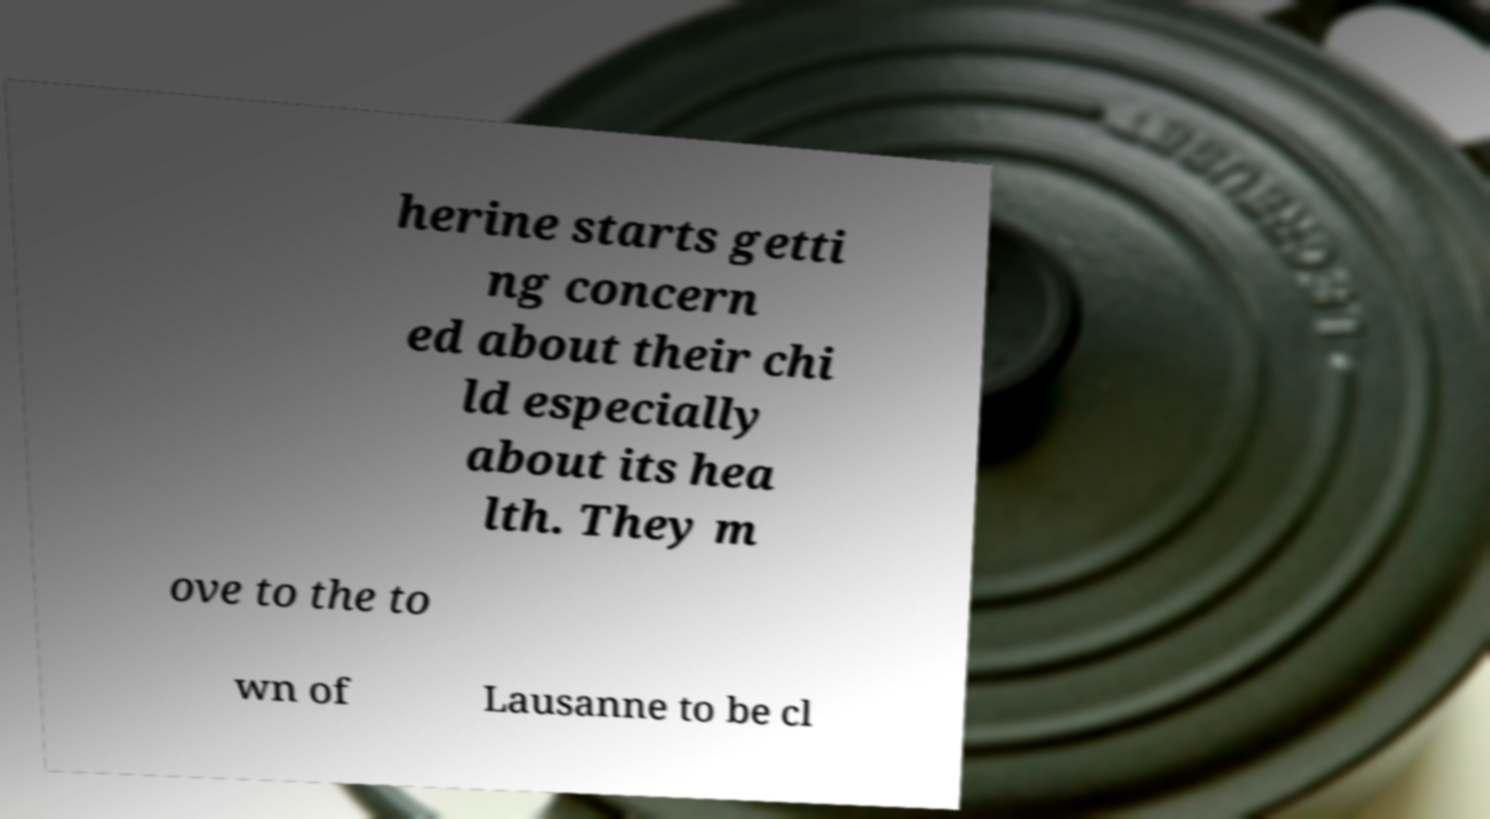Please identify and transcribe the text found in this image. herine starts getti ng concern ed about their chi ld especially about its hea lth. They m ove to the to wn of Lausanne to be cl 